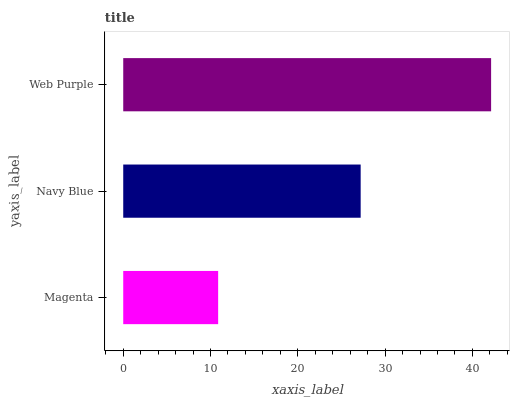Is Magenta the minimum?
Answer yes or no. Yes. Is Web Purple the maximum?
Answer yes or no. Yes. Is Navy Blue the minimum?
Answer yes or no. No. Is Navy Blue the maximum?
Answer yes or no. No. Is Navy Blue greater than Magenta?
Answer yes or no. Yes. Is Magenta less than Navy Blue?
Answer yes or no. Yes. Is Magenta greater than Navy Blue?
Answer yes or no. No. Is Navy Blue less than Magenta?
Answer yes or no. No. Is Navy Blue the high median?
Answer yes or no. Yes. Is Navy Blue the low median?
Answer yes or no. Yes. Is Web Purple the high median?
Answer yes or no. No. Is Web Purple the low median?
Answer yes or no. No. 